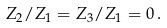<formula> <loc_0><loc_0><loc_500><loc_500>Z _ { 2 } / Z _ { 1 } = Z _ { 3 } / Z _ { 1 } = 0 \, .</formula> 